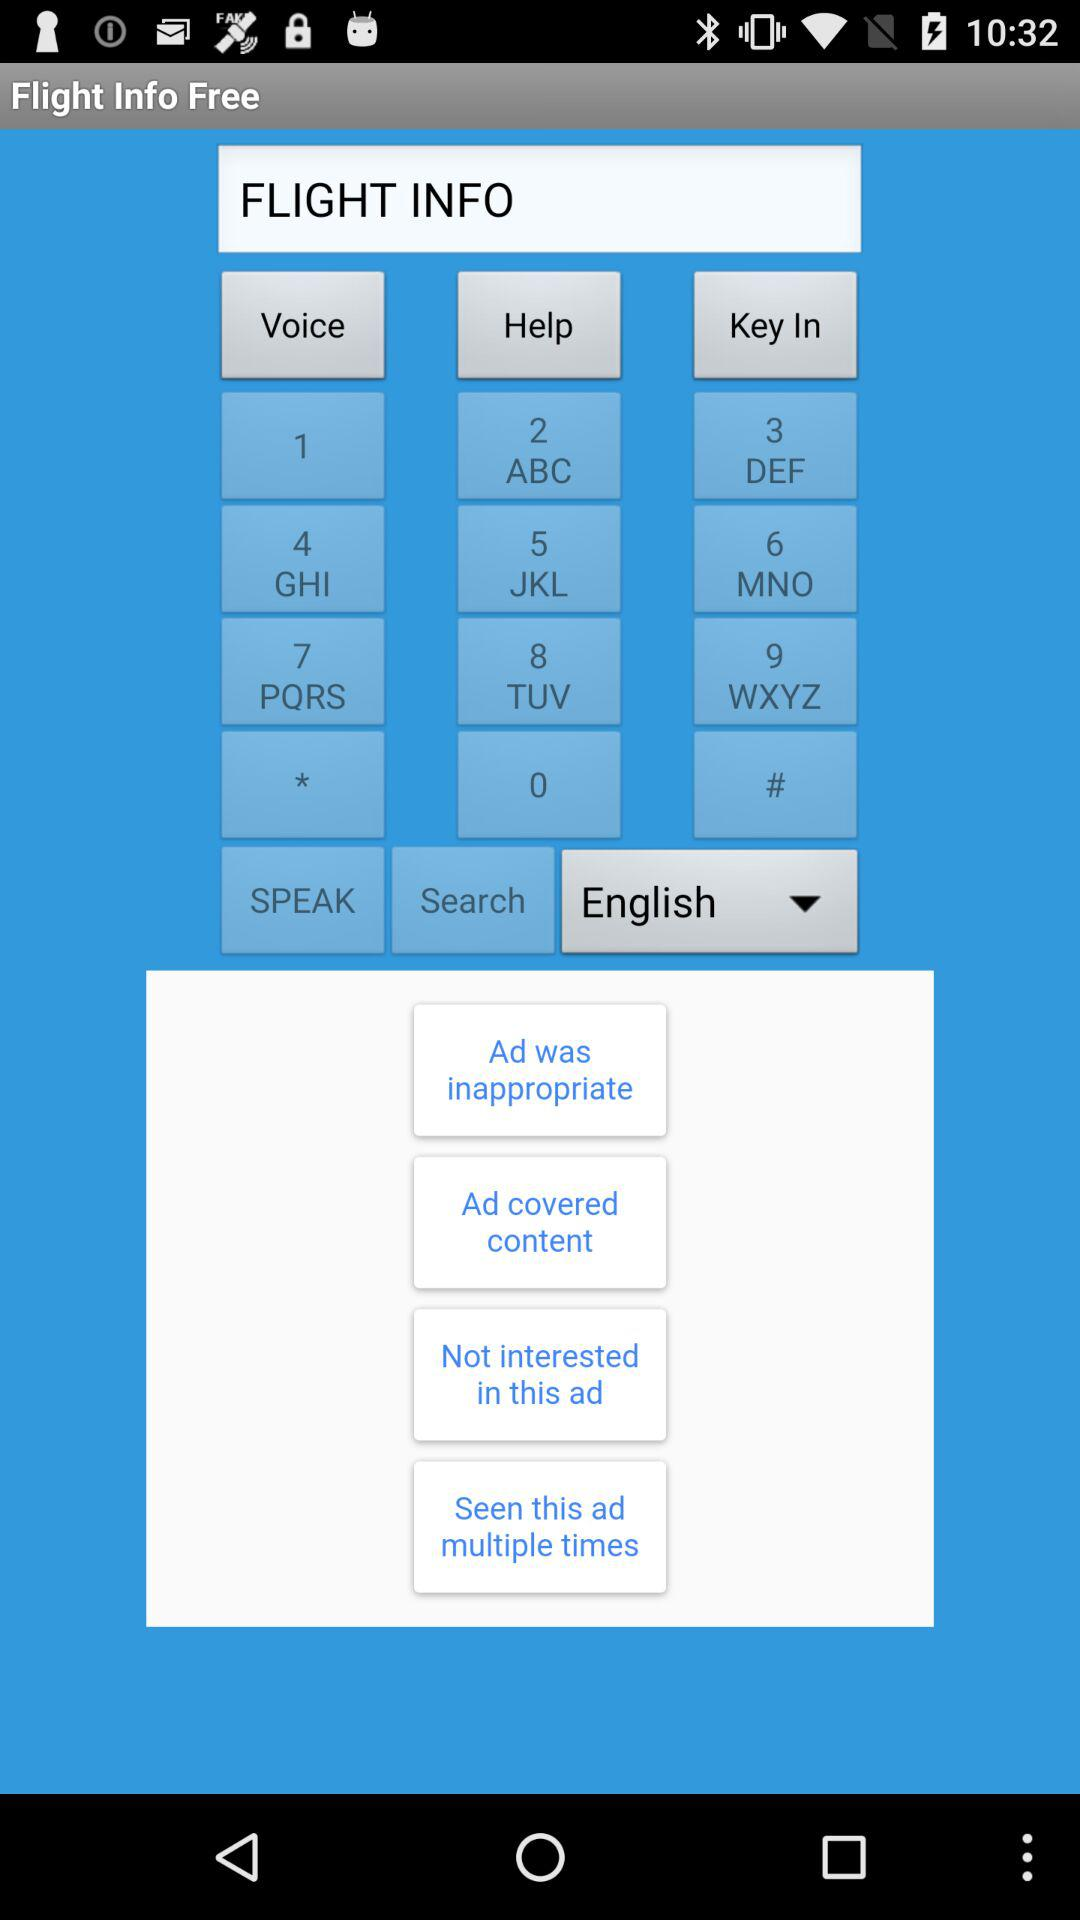What language is selected? The selected language is "English". 